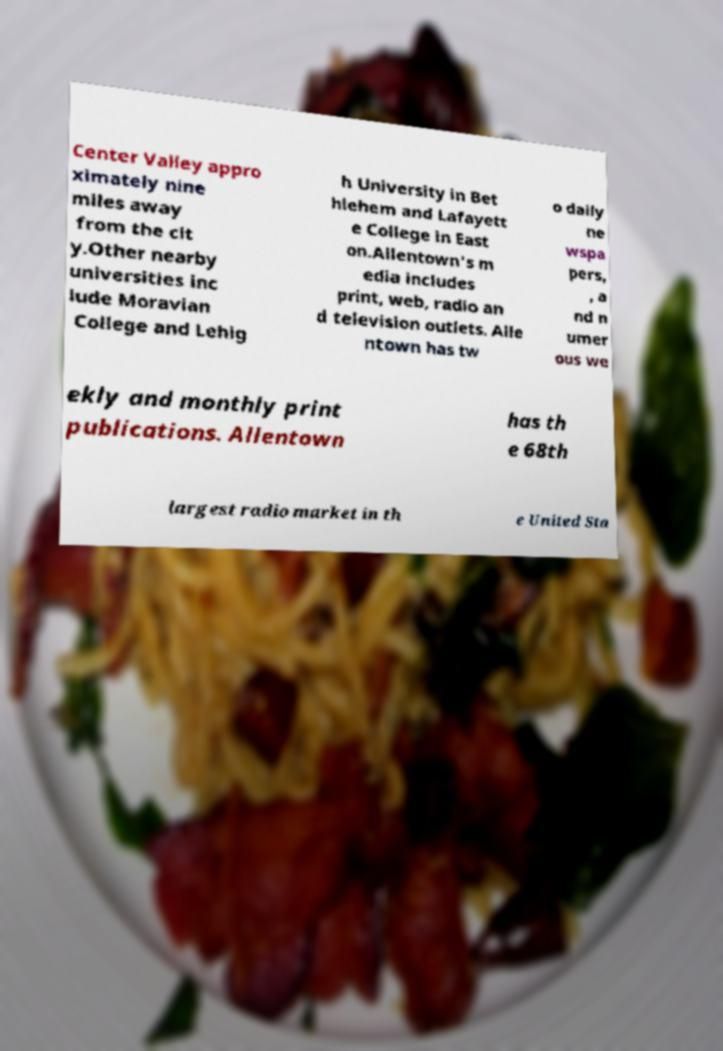Please identify and transcribe the text found in this image. Center Valley appro ximately nine miles away from the cit y.Other nearby universities inc lude Moravian College and Lehig h University in Bet hlehem and Lafayett e College in East on.Allentown's m edia includes print, web, radio an d television outlets. Alle ntown has tw o daily ne wspa pers, , a nd n umer ous we ekly and monthly print publications. Allentown has th e 68th largest radio market in th e United Sta 